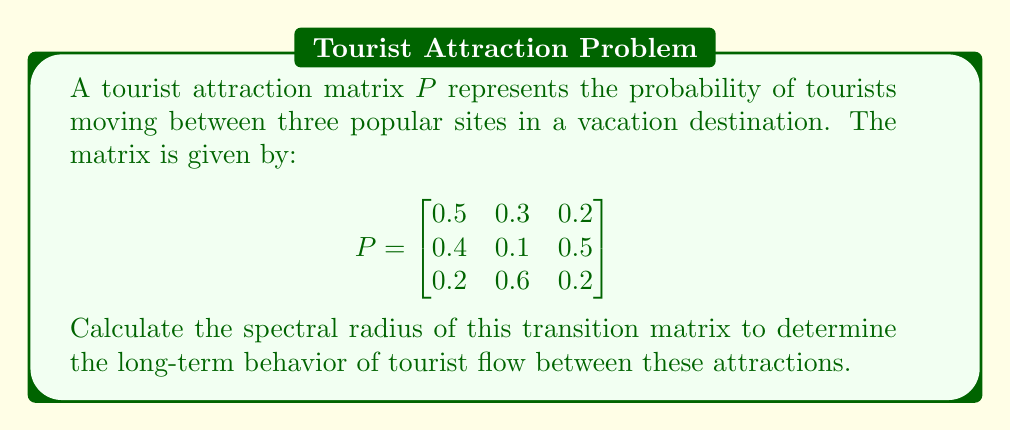Solve this math problem. To find the spectral radius of the transition matrix $P$, we need to follow these steps:

1) First, calculate the characteristic polynomial of $P$:
   $\det(P - \lambda I) = 0$

   $$\begin{vmatrix}
   0.5-\lambda & 0.3 & 0.2 \\
   0.4 & 0.1-\lambda & 0.5 \\
   0.2 & 0.6 & 0.2-\lambda
   \end{vmatrix} = 0$$

2) Expand the determinant:
   $(0.5-\lambda)[(0.1-\lambda)(0.2-\lambda)-0.3] - 0.3[0.4(0.2-\lambda)-0.1] + 0.2[0.4(0.6)-0.5(0.1-\lambda)] = 0$

3) Simplify:
   $-\lambda^3 + 0.8\lambda^2 + 0.33\lambda - 0.13 = 0$

4) Solve this cubic equation. The roots are the eigenvalues of $P$. Using a numerical method or computer algebra system, we find:
   $\lambda_1 \approx 1$
   $\lambda_2 \approx -0.1$
   $\lambda_3 \approx -0.1$

5) The spectral radius $\rho(P)$ is the maximum absolute value of the eigenvalues:
   $\rho(P) = \max\{|\lambda_1|, |\lambda_2|, |\lambda_3|\} = \max\{1, 0.1, 0.1\} = 1$

The spectral radius being 1 indicates that the Markov chain is regular and will converge to a unique stationary distribution, representing the long-term distribution of tourists among the attractions.
Answer: $\rho(P) = 1$ 